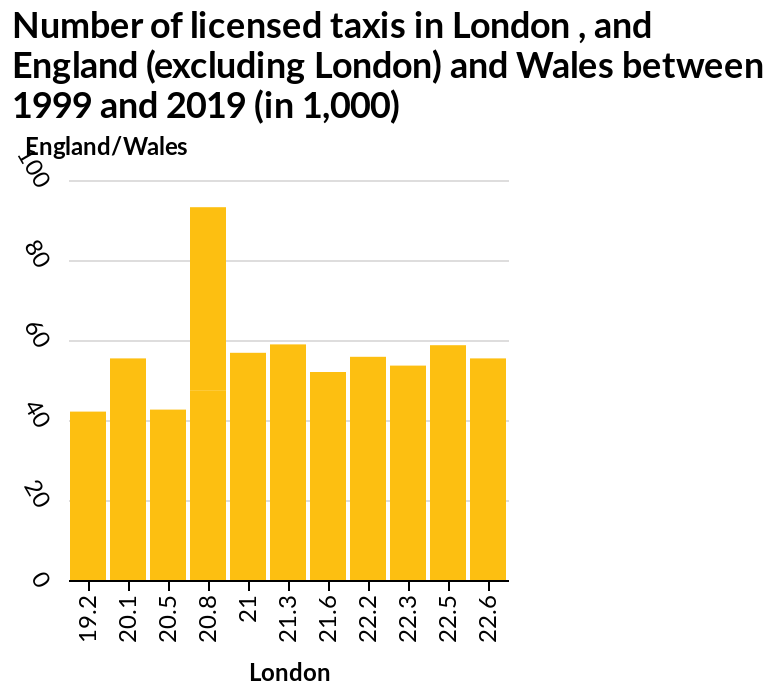<image>
What is the title of the bar plot? The description does not mention the title of the bar plot. How many licensed taxis were there in London at the lowest points on the y-axis? The number of licensed taxis in London at the lowest points on the y-axis was not specified in the description. 